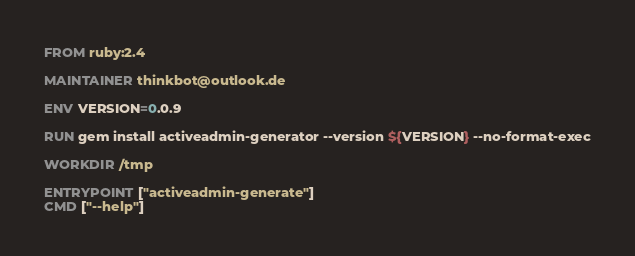Convert code to text. <code><loc_0><loc_0><loc_500><loc_500><_Dockerfile_>FROM ruby:2.4

MAINTAINER thinkbot@outlook.de

ENV VERSION=0.0.9

RUN gem install activeadmin-generator --version ${VERSION} --no-format-exec

WORKDIR /tmp

ENTRYPOINT ["activeadmin-generate"]
CMD ["--help"]
</code> 